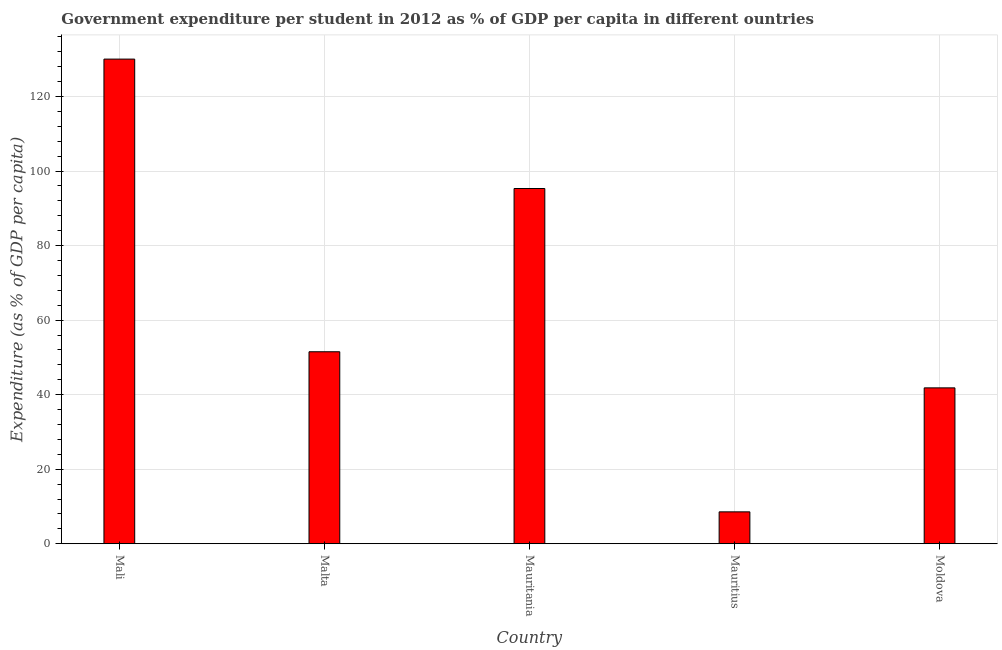Does the graph contain grids?
Make the answer very short. Yes. What is the title of the graph?
Your response must be concise. Government expenditure per student in 2012 as % of GDP per capita in different ountries. What is the label or title of the Y-axis?
Keep it short and to the point. Expenditure (as % of GDP per capita). What is the government expenditure per student in Moldova?
Offer a very short reply. 41.83. Across all countries, what is the maximum government expenditure per student?
Provide a short and direct response. 130.04. Across all countries, what is the minimum government expenditure per student?
Offer a terse response. 8.56. In which country was the government expenditure per student maximum?
Your answer should be very brief. Mali. In which country was the government expenditure per student minimum?
Your answer should be compact. Mauritius. What is the sum of the government expenditure per student?
Ensure brevity in your answer.  327.27. What is the difference between the government expenditure per student in Mauritius and Moldova?
Keep it short and to the point. -33.27. What is the average government expenditure per student per country?
Keep it short and to the point. 65.45. What is the median government expenditure per student?
Offer a very short reply. 51.52. What is the ratio of the government expenditure per student in Mauritania to that in Mauritius?
Make the answer very short. 11.14. What is the difference between the highest and the second highest government expenditure per student?
Your response must be concise. 34.72. What is the difference between the highest and the lowest government expenditure per student?
Provide a short and direct response. 121.49. What is the Expenditure (as % of GDP per capita) of Mali?
Offer a terse response. 130.04. What is the Expenditure (as % of GDP per capita) in Malta?
Your response must be concise. 51.52. What is the Expenditure (as % of GDP per capita) of Mauritania?
Keep it short and to the point. 95.32. What is the Expenditure (as % of GDP per capita) in Mauritius?
Your response must be concise. 8.56. What is the Expenditure (as % of GDP per capita) of Moldova?
Your answer should be very brief. 41.83. What is the difference between the Expenditure (as % of GDP per capita) in Mali and Malta?
Your response must be concise. 78.53. What is the difference between the Expenditure (as % of GDP per capita) in Mali and Mauritania?
Your answer should be very brief. 34.72. What is the difference between the Expenditure (as % of GDP per capita) in Mali and Mauritius?
Ensure brevity in your answer.  121.49. What is the difference between the Expenditure (as % of GDP per capita) in Mali and Moldova?
Offer a very short reply. 88.22. What is the difference between the Expenditure (as % of GDP per capita) in Malta and Mauritania?
Give a very brief answer. -43.8. What is the difference between the Expenditure (as % of GDP per capita) in Malta and Mauritius?
Offer a very short reply. 42.96. What is the difference between the Expenditure (as % of GDP per capita) in Malta and Moldova?
Offer a terse response. 9.69. What is the difference between the Expenditure (as % of GDP per capita) in Mauritania and Mauritius?
Keep it short and to the point. 86.76. What is the difference between the Expenditure (as % of GDP per capita) in Mauritania and Moldova?
Keep it short and to the point. 53.49. What is the difference between the Expenditure (as % of GDP per capita) in Mauritius and Moldova?
Provide a succinct answer. -33.27. What is the ratio of the Expenditure (as % of GDP per capita) in Mali to that in Malta?
Ensure brevity in your answer.  2.52. What is the ratio of the Expenditure (as % of GDP per capita) in Mali to that in Mauritania?
Offer a terse response. 1.36. What is the ratio of the Expenditure (as % of GDP per capita) in Mali to that in Mauritius?
Make the answer very short. 15.2. What is the ratio of the Expenditure (as % of GDP per capita) in Mali to that in Moldova?
Provide a succinct answer. 3.11. What is the ratio of the Expenditure (as % of GDP per capita) in Malta to that in Mauritania?
Your answer should be very brief. 0.54. What is the ratio of the Expenditure (as % of GDP per capita) in Malta to that in Mauritius?
Your response must be concise. 6.02. What is the ratio of the Expenditure (as % of GDP per capita) in Malta to that in Moldova?
Your answer should be compact. 1.23. What is the ratio of the Expenditure (as % of GDP per capita) in Mauritania to that in Mauritius?
Your response must be concise. 11.14. What is the ratio of the Expenditure (as % of GDP per capita) in Mauritania to that in Moldova?
Your response must be concise. 2.28. What is the ratio of the Expenditure (as % of GDP per capita) in Mauritius to that in Moldova?
Offer a terse response. 0.2. 